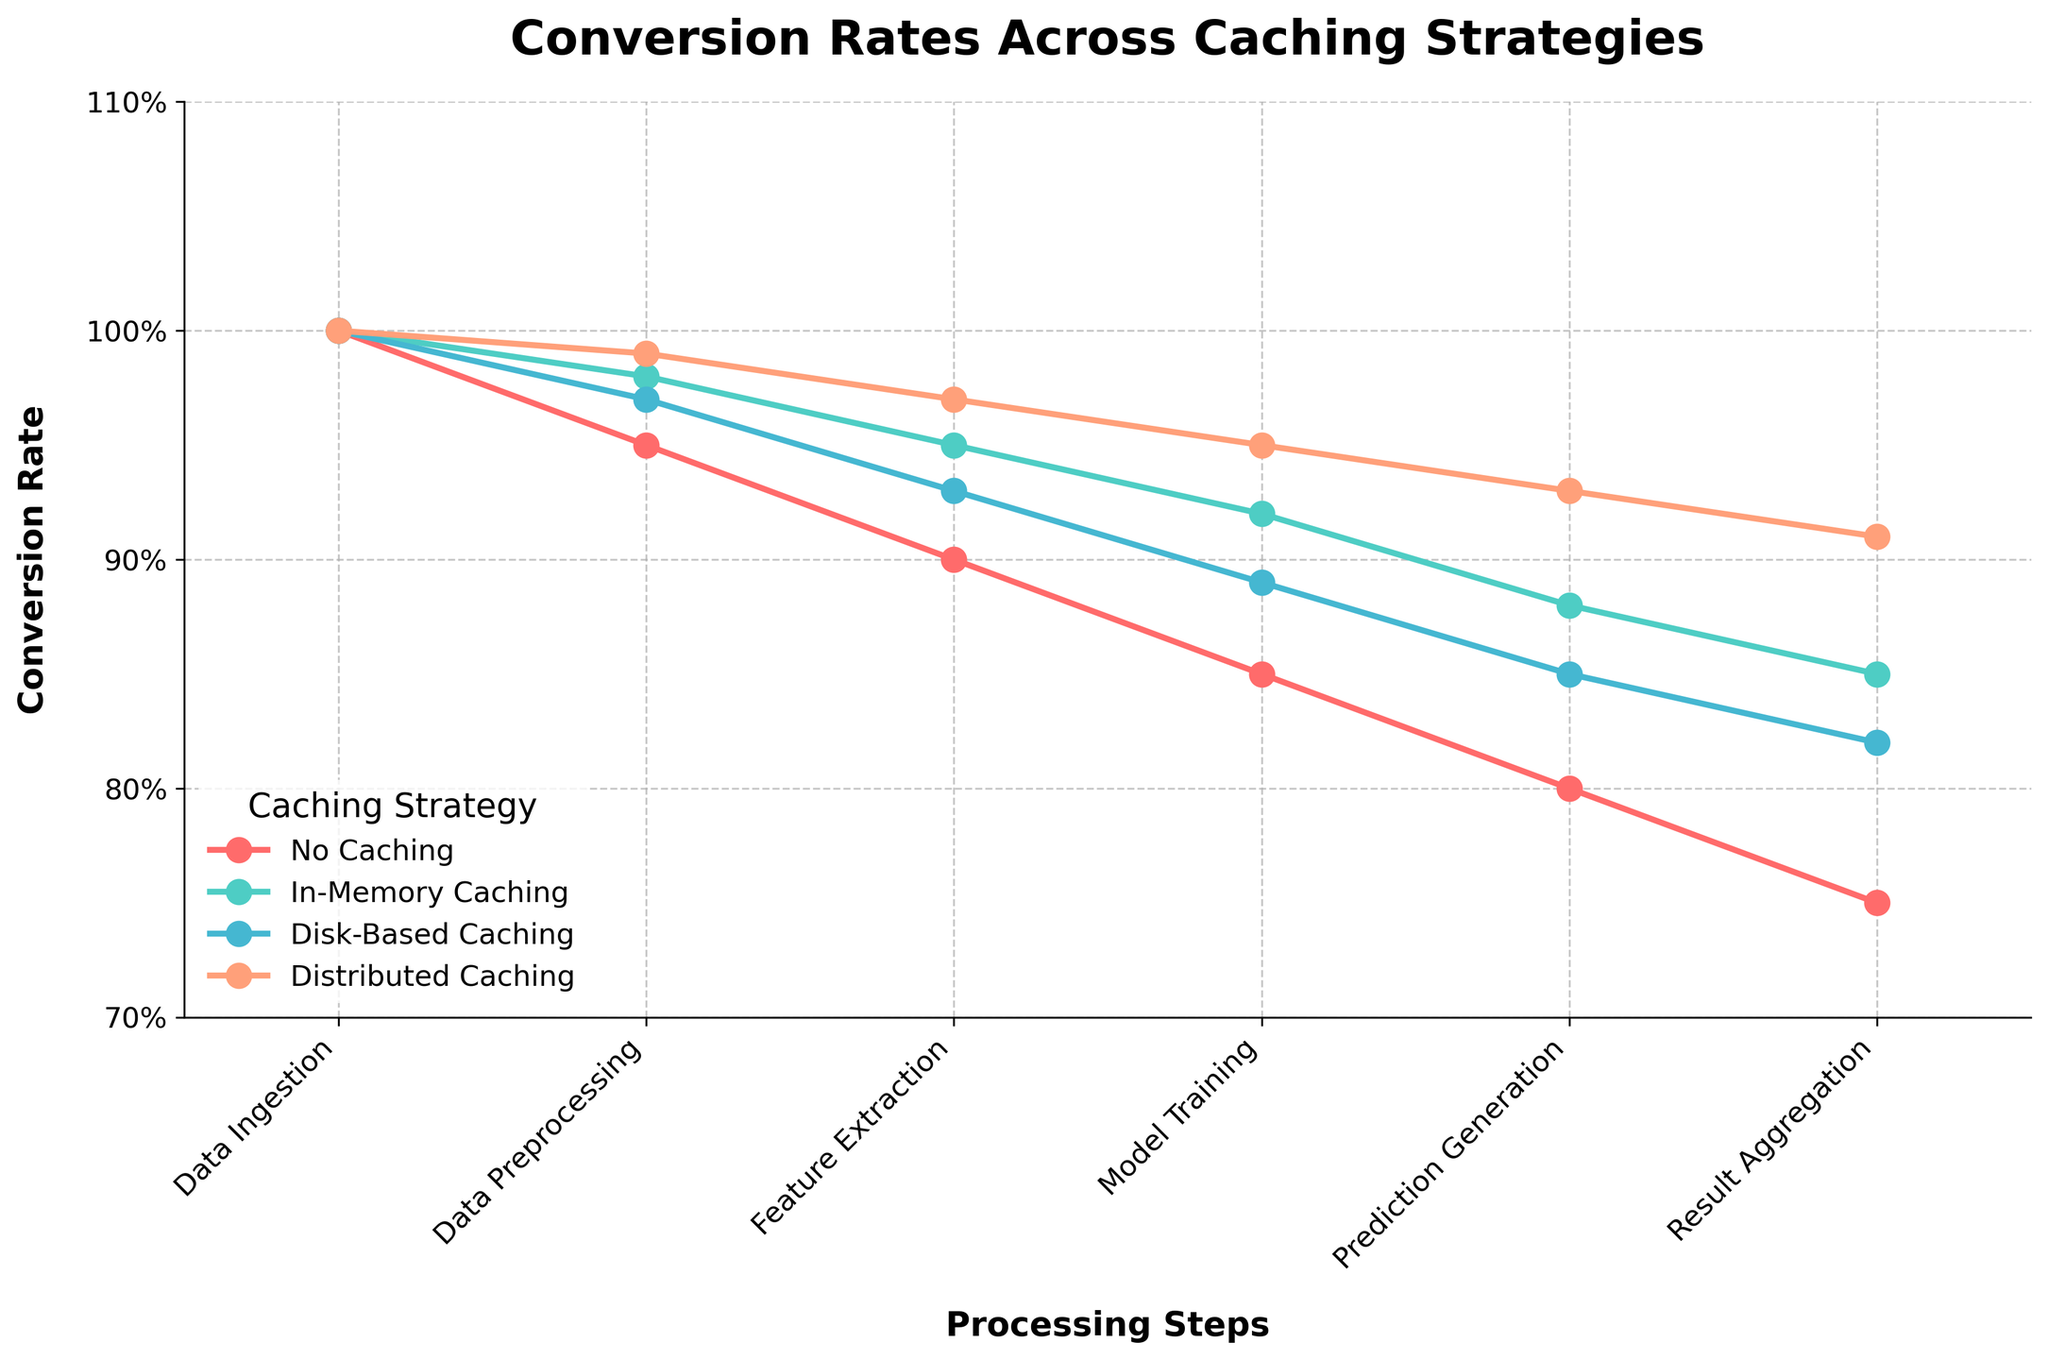What is the title of the figure? The title of a figure is usually displayed at the top of the graph. The title in this case would describe what the graph is about.
Answer: Conversion Rates Across Caching Strategies What caching strategy has the highest conversion rate at the "Data Preprocessing" step? To determine which caching strategy has the highest conversion rate, compare the conversion rates under the "Data Preprocessing" step for each strategy.
Answer: Distributed Caching How does the conversion rate of "In-Memory Caching" change from "Data Ingestion" to "Result Aggregation"? Look at the conversion rates for "In-Memory Caching" at each step from "Data Ingestion" to "Result Aggregation" to identify the change.
Answer: It decreases from 100% to 85% Which step shows the largest drop in conversion rate for the "No Caching" strategy? By comparing the conversion rates across all steps in the "No Caching" strategy, identify the step with the largest difference between consecutive steps.
Answer: Data Preprocessing to Feature Extraction How does the "Distributed Caching" strategy perform compared to "No Caching" at the "Model Training" step? To find the performance comparison, look at the conversion rates for both strategies at the "Model Training" step.
Answer: Distributed Caching performs 10% better Rank the caching strategies from highest to lowest at the "Prediction Generation" step. Check the conversion rates for each caching strategy at the "Prediction Generation" step and rank them accordingly.
Answer: Distributed Caching, In-Memory Caching, Disk-Based Caching, No Caching Which caching strategy maintains above 90% conversion throughout all steps? For each caching strategy, check if the conversion rates are above 90% at all steps.
Answer: Distributed Caching What is the average conversion rate for "Disk-Based Caching" across all steps? Sum the conversion rates of "Disk-Based Caching" across all steps and divide by the number of steps.
Answer: (100% + 97% + 93% + 89% + 85% + 82%) / 6 = 91% At which step is the conversion rate difference between "No Caching" and "In-Memory Caching" the greatest? Calculate the difference between the conversion rates of "No Caching" and "In-Memory Caching" for each step, and identify the step with the largest difference.
Answer: Feature Extraction 